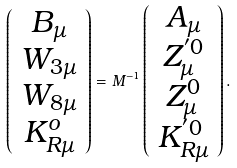<formula> <loc_0><loc_0><loc_500><loc_500>\left ( \begin{array} { c } B _ { \mu } \\ W _ { 3 \mu } \\ W _ { 8 \mu } \\ K _ { R \mu } ^ { o } \end{array} \right ) = M ^ { - 1 } \left ( \begin{array} { c } A _ { \mu } \\ Z _ { \mu } ^ { ^ { \prime } 0 } \\ Z _ { \mu } ^ { 0 } \\ K _ { { R } \mu } ^ { ^ { \prime } 0 } \end{array} \right ) .</formula> 